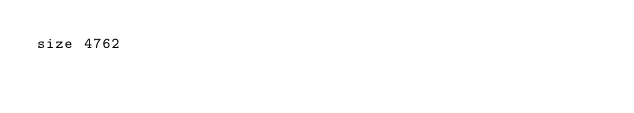<code> <loc_0><loc_0><loc_500><loc_500><_ObjectiveC_>size 4762
</code> 